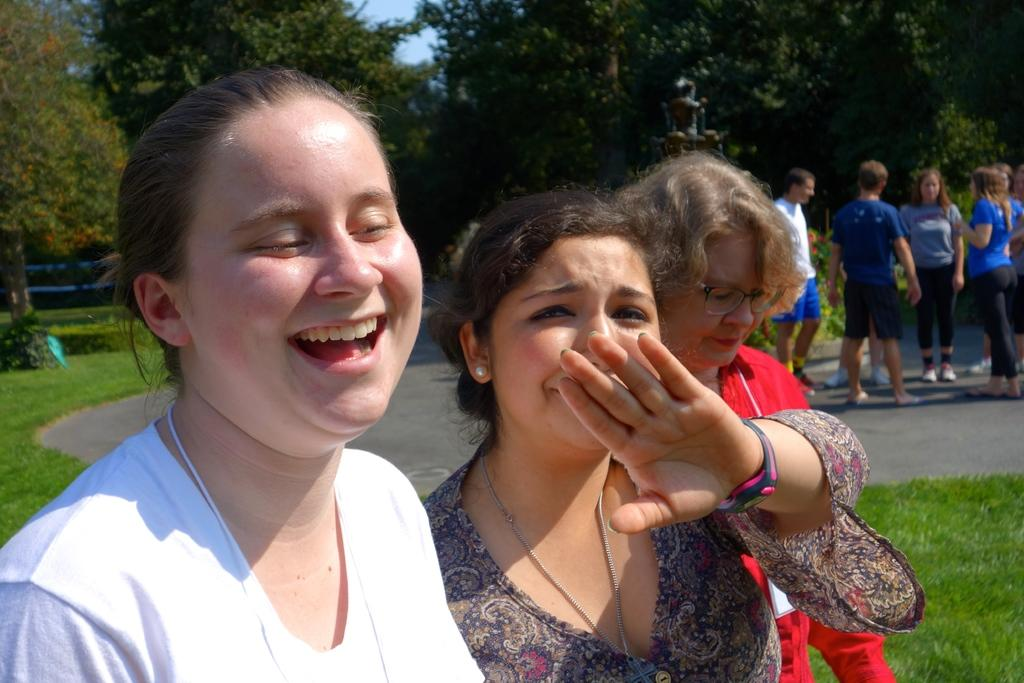How many people are in the image? There are people in the image, but the exact number is not specified. What is the expression of the woman in the image? A woman is smiling in the image. What can be seen in the background of the image? There are trees, the sky, and grass in the background of the image. What type of rainstorm is occurring in the image? There is no rainstorm present in the image; the sky is visible in the background, but no rain is depicted. 